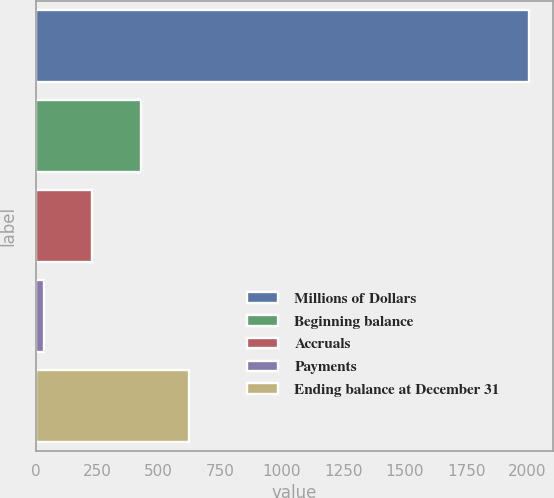<chart> <loc_0><loc_0><loc_500><loc_500><bar_chart><fcel>Millions of Dollars<fcel>Beginning balance<fcel>Accruals<fcel>Payments<fcel>Ending balance at December 31<nl><fcel>2004<fcel>426.4<fcel>229.2<fcel>32<fcel>623.6<nl></chart> 